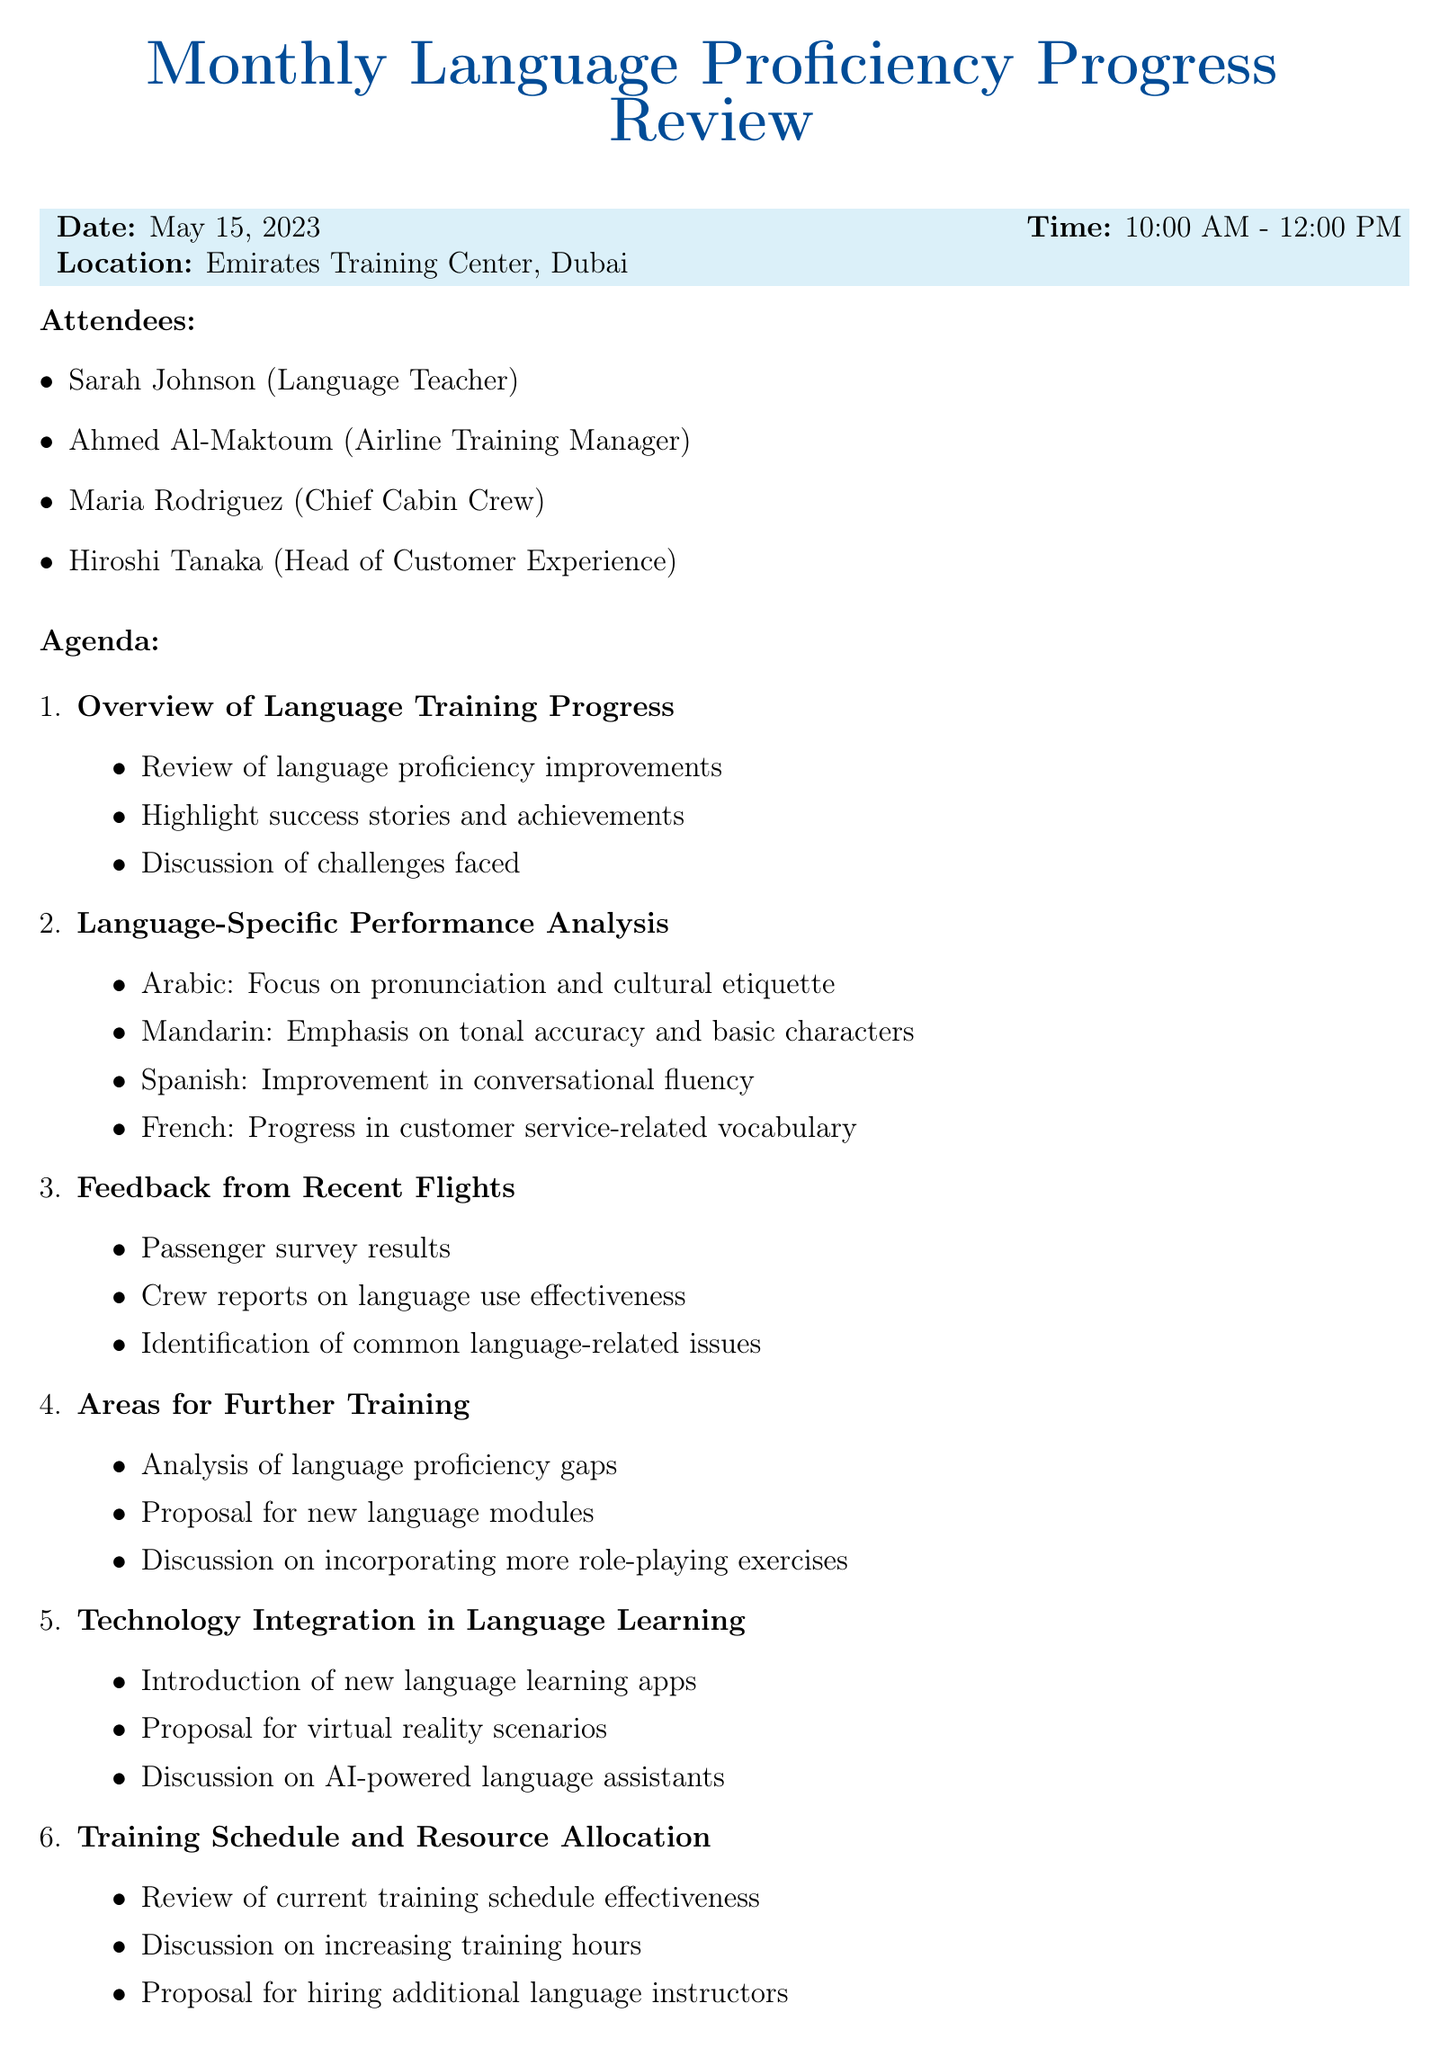what is the meeting title? The title of the meeting is stated at the top of the document as "Monthly Language Proficiency Progress Review."
Answer: Monthly Language Proficiency Progress Review when is the meeting scheduled? The document specifies the date of the meeting as May 15, 2023.
Answer: May 15, 2023 who is the Airline Training Manager? The document lists Ahmed Al-Maktoum as the Airline Training Manager among the attendees.
Answer: Ahmed Al-Maktoum what is one of the focus areas for Arabic language training? The agenda includes "Focus on pronunciation and cultural etiquette" as a specific area for Arabic training.
Answer: pronunciation and cultural etiquette what action item involves technology? The document mentions "Implement new technology solutions for language learning" as an action item.
Answer: Implement new technology solutions for language learning which languages are discussed in the language-specific performance analysis? The document lists Arabic, Mandarin, Spanish, and French as the languages discussed in the performance analysis.
Answer: Arabic, Mandarin, Spanish, French how many attendees are listed in total? There are four attendees listed in the document, which includes Sarah Johnson, Ahmed Al-Maktoum, Maria Rodriguez, and Hiroshi Tanaka.
Answer: 4 what is the proposed new language module mentioned for further training? The agenda item proposes "new language modules (e.g., basic German, Italian)" for further training.
Answer: basic German, Italian 